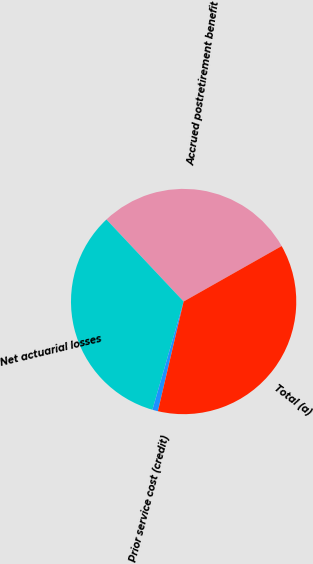Convert chart to OTSL. <chart><loc_0><loc_0><loc_500><loc_500><pie_chart><fcel>Accrued postretirement benefit<fcel>Net actuarial losses<fcel>Prior service cost (credit)<fcel>Total (a)<nl><fcel>28.82%<fcel>33.51%<fcel>0.8%<fcel>36.86%<nl></chart> 